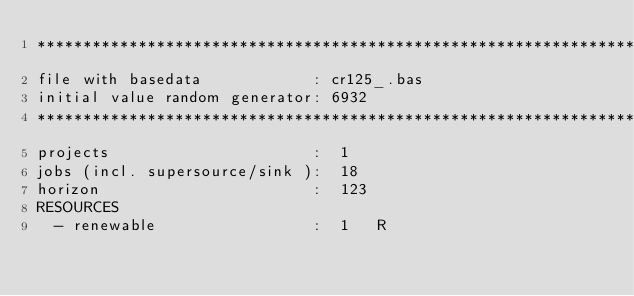<code> <loc_0><loc_0><loc_500><loc_500><_ObjectiveC_>************************************************************************
file with basedata            : cr125_.bas
initial value random generator: 6932
************************************************************************
projects                      :  1
jobs (incl. supersource/sink ):  18
horizon                       :  123
RESOURCES
  - renewable                 :  1   R</code> 